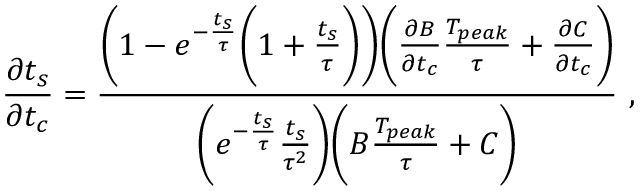Convert formula to latex. <formula><loc_0><loc_0><loc_500><loc_500>\frac { \partial t _ { s } } { \partial t _ { c } } = \frac { \left ( 1 - e ^ { - \frac { t _ { s } } { \tau } } \left ( 1 + \frac { t _ { s } } { \tau } \right ) \right ) \left ( \frac { \partial B } { \partial t _ { c } } \frac { T _ { p e a k } } { \tau } + \frac { \partial C } { \partial t _ { c } } \right ) } { \left ( e ^ { - \frac { t _ { s } } { \tau } } \frac { t _ { s } } { \tau ^ { 2 } } \right ) \left ( B \frac { T _ { p e a k } } { \tau } + C \right ) } ,</formula> 